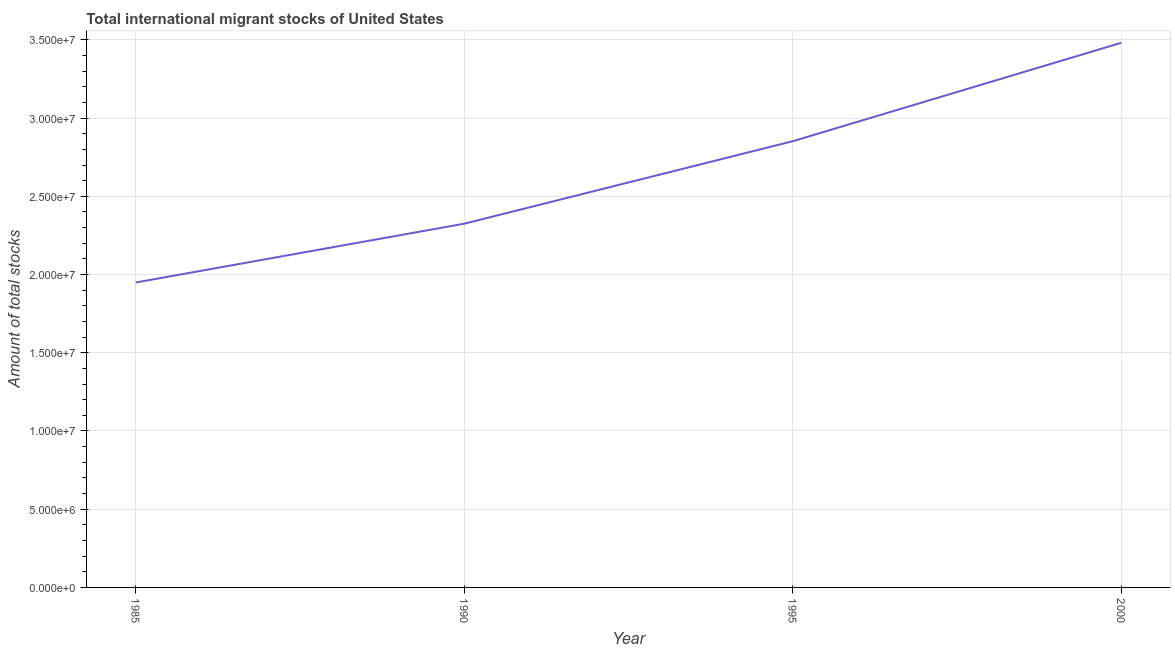What is the total number of international migrant stock in 1995?
Ensure brevity in your answer.  2.85e+07. Across all years, what is the maximum total number of international migrant stock?
Your answer should be very brief. 3.48e+07. Across all years, what is the minimum total number of international migrant stock?
Provide a short and direct response. 1.95e+07. What is the sum of the total number of international migrant stock?
Make the answer very short. 1.06e+08. What is the difference between the total number of international migrant stock in 1985 and 1995?
Provide a short and direct response. -9.03e+06. What is the average total number of international migrant stock per year?
Give a very brief answer. 2.65e+07. What is the median total number of international migrant stock?
Make the answer very short. 2.59e+07. Do a majority of the years between 1990 and 2000 (inclusive) have total number of international migrant stock greater than 24000000 ?
Provide a short and direct response. Yes. What is the ratio of the total number of international migrant stock in 1985 to that in 1990?
Make the answer very short. 0.84. Is the total number of international migrant stock in 1995 less than that in 2000?
Offer a terse response. Yes. Is the difference between the total number of international migrant stock in 1990 and 2000 greater than the difference between any two years?
Give a very brief answer. No. What is the difference between the highest and the second highest total number of international migrant stock?
Give a very brief answer. 6.29e+06. What is the difference between the highest and the lowest total number of international migrant stock?
Provide a succinct answer. 1.53e+07. In how many years, is the total number of international migrant stock greater than the average total number of international migrant stock taken over all years?
Give a very brief answer. 2. Are the values on the major ticks of Y-axis written in scientific E-notation?
Ensure brevity in your answer.  Yes. What is the title of the graph?
Give a very brief answer. Total international migrant stocks of United States. What is the label or title of the Y-axis?
Your answer should be compact. Amount of total stocks. What is the Amount of total stocks of 1985?
Your answer should be very brief. 1.95e+07. What is the Amount of total stocks of 1990?
Your answer should be very brief. 2.33e+07. What is the Amount of total stocks of 1995?
Offer a terse response. 2.85e+07. What is the Amount of total stocks in 2000?
Offer a terse response. 3.48e+07. What is the difference between the Amount of total stocks in 1985 and 1990?
Your response must be concise. -3.76e+06. What is the difference between the Amount of total stocks in 1985 and 1995?
Your response must be concise. -9.03e+06. What is the difference between the Amount of total stocks in 1985 and 2000?
Your response must be concise. -1.53e+07. What is the difference between the Amount of total stocks in 1990 and 1995?
Give a very brief answer. -5.27e+06. What is the difference between the Amount of total stocks in 1990 and 2000?
Make the answer very short. -1.16e+07. What is the difference between the Amount of total stocks in 1995 and 2000?
Give a very brief answer. -6.29e+06. What is the ratio of the Amount of total stocks in 1985 to that in 1990?
Your answer should be very brief. 0.84. What is the ratio of the Amount of total stocks in 1985 to that in 1995?
Provide a short and direct response. 0.68. What is the ratio of the Amount of total stocks in 1985 to that in 2000?
Keep it short and to the point. 0.56. What is the ratio of the Amount of total stocks in 1990 to that in 1995?
Offer a very short reply. 0.81. What is the ratio of the Amount of total stocks in 1990 to that in 2000?
Give a very brief answer. 0.67. What is the ratio of the Amount of total stocks in 1995 to that in 2000?
Your answer should be compact. 0.82. 